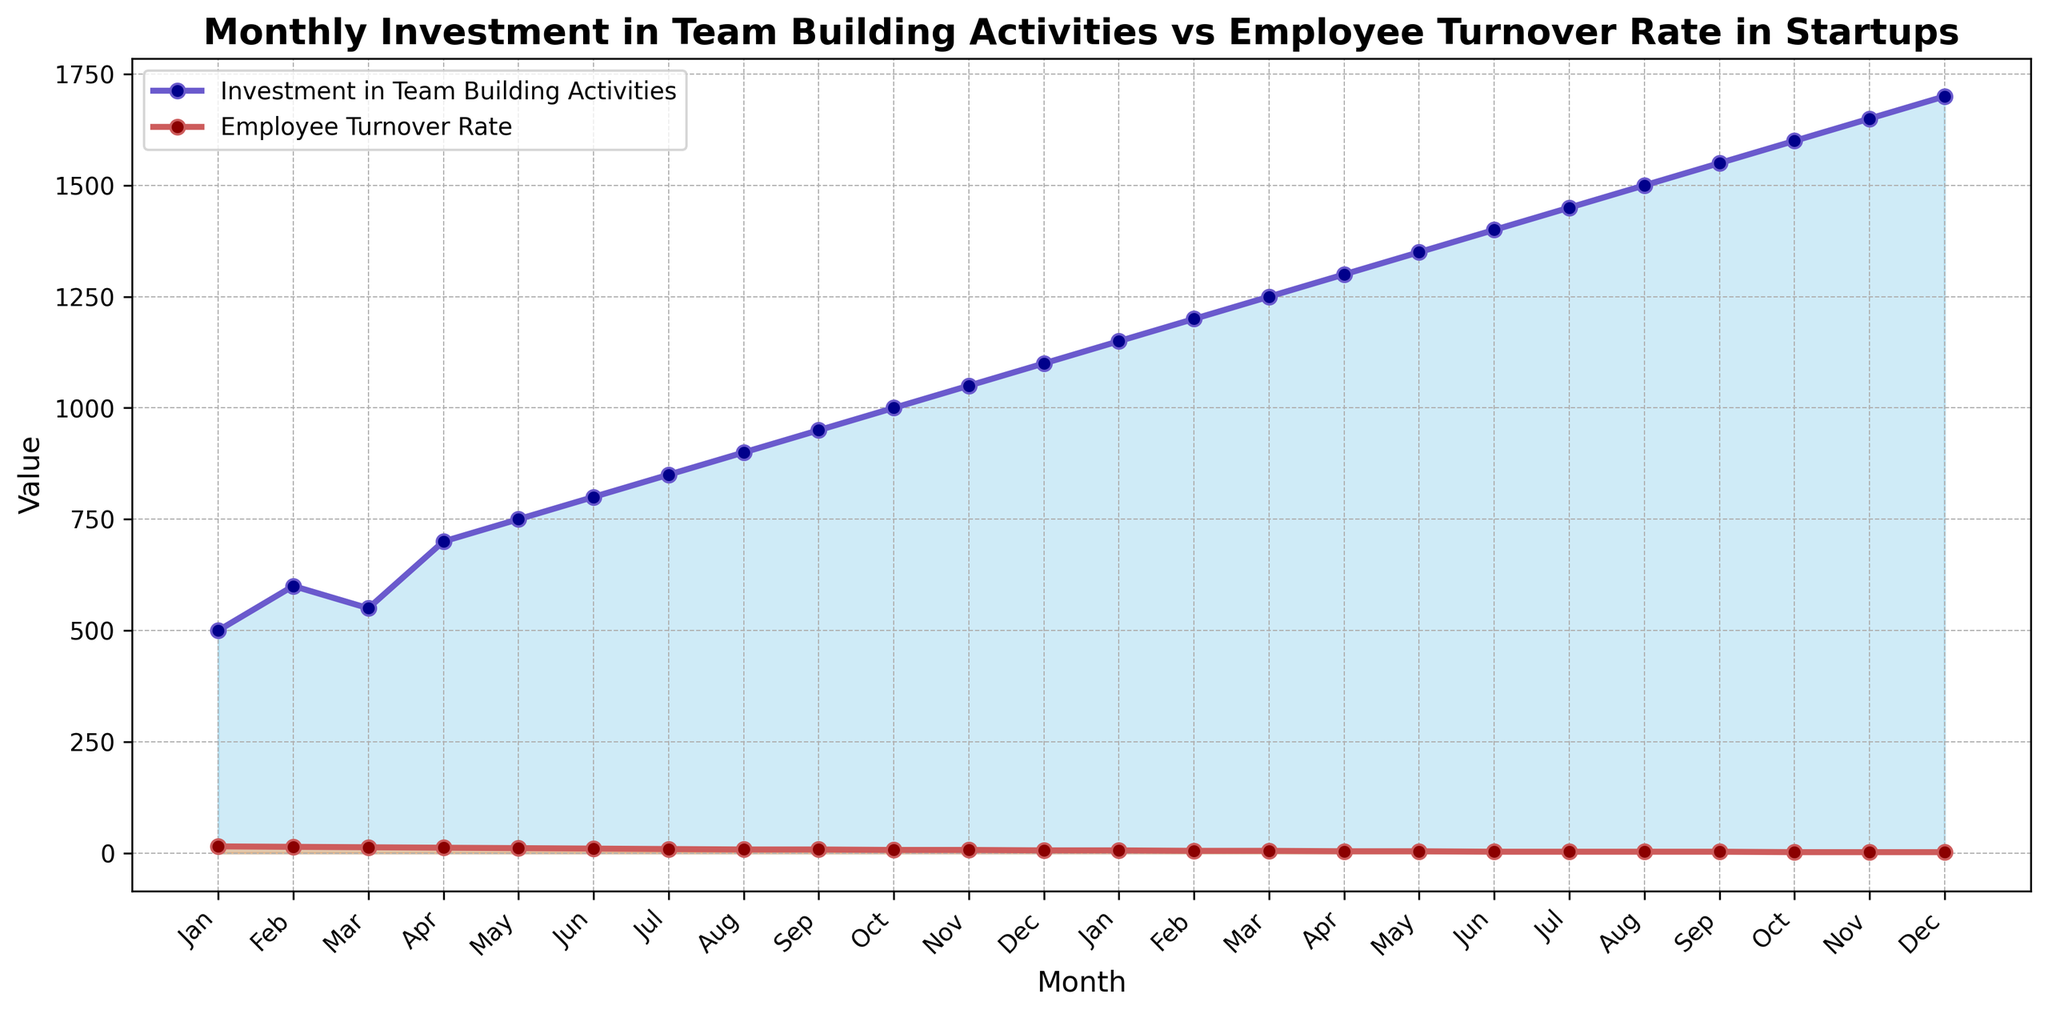What's the general trend observed for Investment in Team Building Activities over the months? The investment in team building activities shows a consistent increase from January with $500 to December with $1700. Each month, the investment grows steadily.
Answer: Increasing How does the employee turnover rate change with the increase in team building activities investment? As the investment in team building activities increases from $500 in January to $1700 in December, the employee turnover rate decreases from 15% to 2%. There is an inverse relationship between the two.
Answer: Decreasing Which month had the highest employee turnover rate and what was the investment in team building activities that month? January had the highest employee turnover rate at 15%, with the investment in team building activities being $500.
Answer: January, $500 What is the difference in employee turnover rate between the month with the lowest investment and the month with the highest investment? The lowest investment month (January) had a turnover rate of 15%, and the highest investment month (December) had a turnover rate of 2%. The difference is 15% - 2% = 13%.
Answer: 13% In which months did the employee turnover rate remain constant despite different levels of investment in team building activities? In August and September, the employee turnover rate remained constant at 8%, although the investments were $900 and $950 respectively.
Answer: August and September By how much did the investment in team building activities increase from July to December, and what change in turnover rate corresponded to this increase? From July to December, investment increased from $850 to $1700, a difference of $850. During the same period, turnover rate reduced from 9% to 2%, a change of 7%.
Answer: $850, 7% What is the average monthly investment in team building activities? To find the average, sum all monthly investments and divide by the number of months. Sum = 500 + 600 + 550 + 700 + 750 + 800 + 850 + 900 + 950 + 1000 + 1050 + 1100 + 1150 + 1200 + 1250 + 1300 + 1350 + 1400 + 1450 + 1500 + 1550 + 1600 + 1650 + 1700 = 29750. Number of months = 24. Average = 29750 / 24 = $1239.58
Answer: $1239.58 Which month showed the largest single-month increase in investment in team building activities, and what was the increase? From February to March in the second recorded year, the investment increased from $1550 to $1600. The increase was $50, which is the largest single-month increase.
Answer: March, $50 